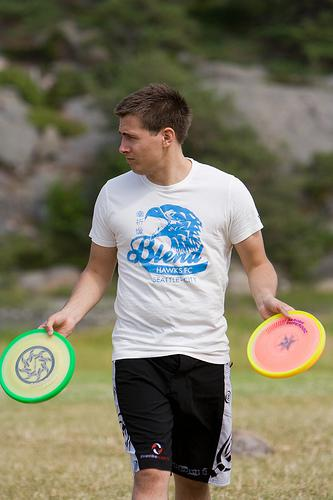Question: what kind of shirt is the man wearing?
Choices:
A. Tank top.
B. Tube top.
C. A t-shirt.
D. Crew top.
Answer with the letter. Answer: C Question: what color hair does the man have?
Choices:
A. Black.
B. Blonde.
C. Red.
D. Brown.
Answer with the letter. Answer: D 